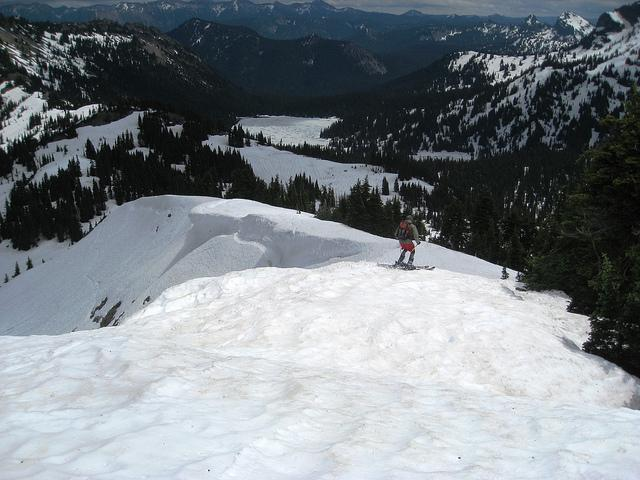From where did this person directly come?

Choices:
A) up high
B) sun valley
C) below
D) ski lodge up high 